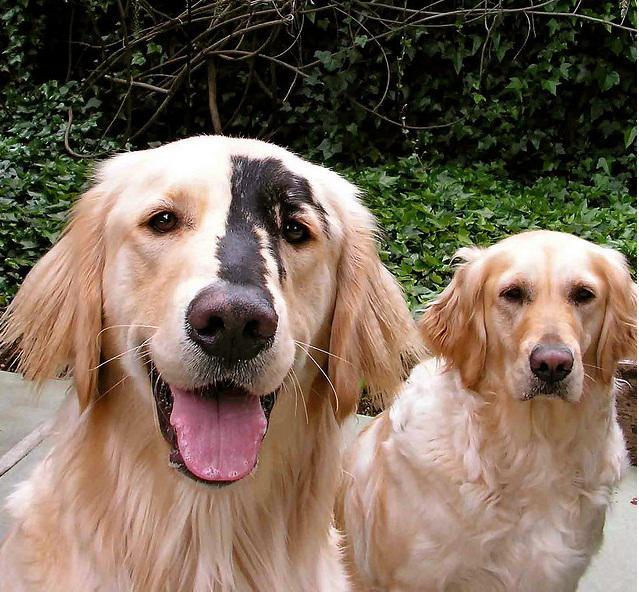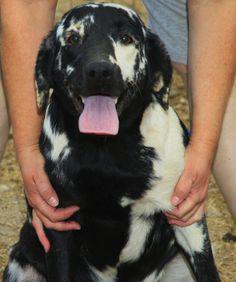The first image is the image on the left, the second image is the image on the right. Considering the images on both sides, is "A dog has orangish-blond fur and a dark uneven stripe that runs from above one eye to its nose." valid? Answer yes or no. Yes. The first image is the image on the left, the second image is the image on the right. For the images shown, is this caption "There are more animals in the image on the left." true? Answer yes or no. Yes. 